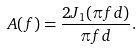Convert formula to latex. <formula><loc_0><loc_0><loc_500><loc_500>A ( f ) = \frac { 2 J _ { 1 } ( \pi f d ) } { \pi f d } .</formula> 